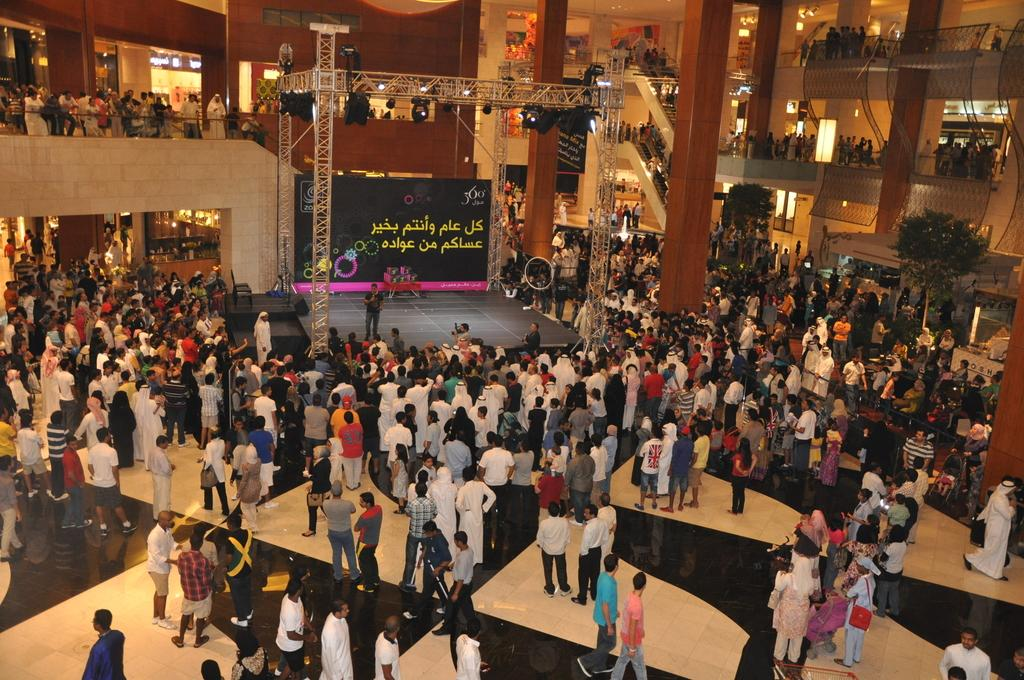What type of location is depicted in the image? The image appears to depict a mall. What is happening at the center stage in the image? An event is being organized at the center stage. How many people are present at the event? Many people are watching the event. What type of air can be seen coming out of the volcano in the image? There is no volcano present in the image; it depicts a mall with an event happening at the center stage. 